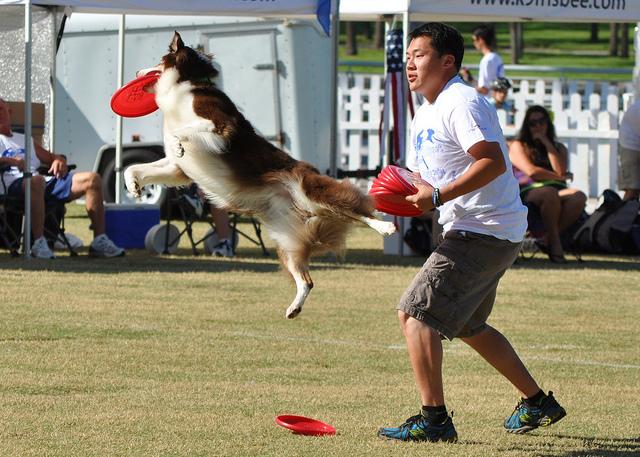What kind of animal is shown?
Quick response, please. Dog. Is this dog good at what he does?
Concise answer only. Yes. Is the dog running?
Short answer required. No. 